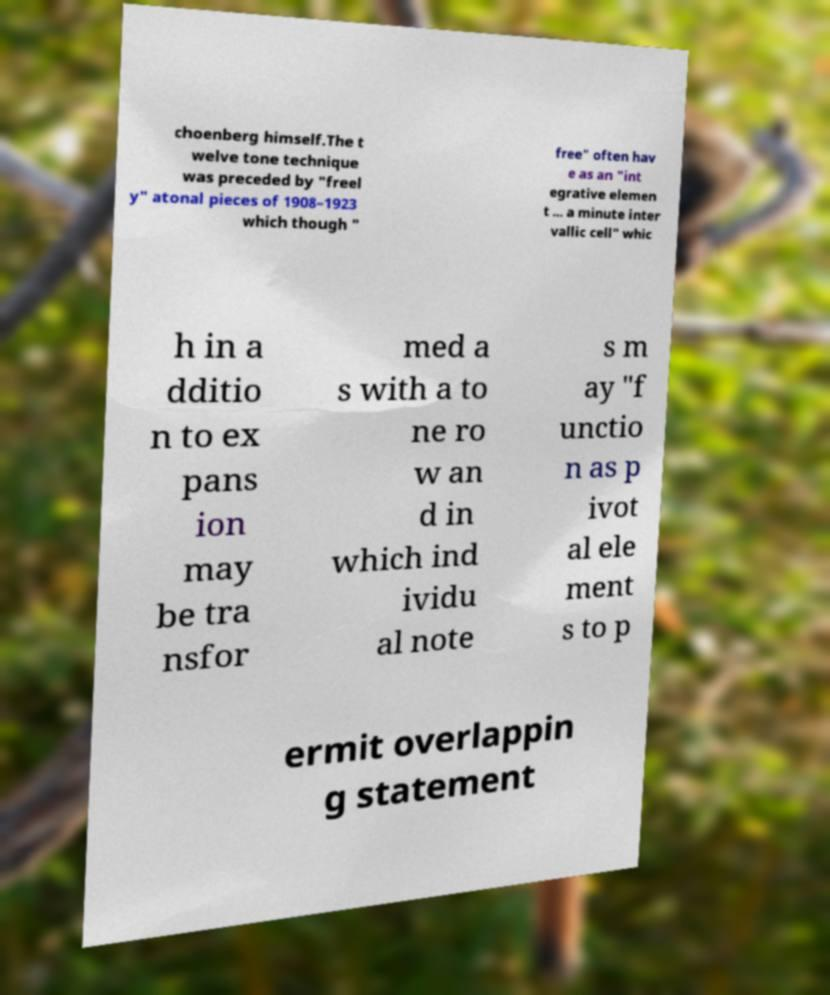I need the written content from this picture converted into text. Can you do that? choenberg himself.The t welve tone technique was preceded by "freel y" atonal pieces of 1908–1923 which though " free" often hav e as an "int egrative elemen t ... a minute inter vallic cell" whic h in a dditio n to ex pans ion may be tra nsfor med a s with a to ne ro w an d in which ind ividu al note s m ay "f unctio n as p ivot al ele ment s to p ermit overlappin g statement 